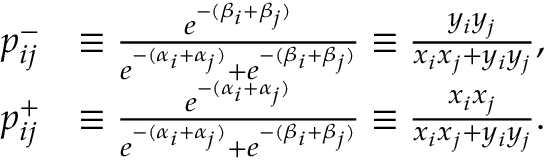Convert formula to latex. <formula><loc_0><loc_0><loc_500><loc_500>\begin{array} { r l } { p _ { i j } ^ { - } } & { \equiv \frac { e ^ { - ( \beta _ { i } + \beta _ { j } ) } } { e ^ { - ( \alpha _ { i } + \alpha _ { j } ) } + e ^ { - ( \beta _ { i } + \beta _ { j } ) } } \equiv \frac { y _ { i } y _ { j } } { x _ { i } x _ { j } + y _ { i } y _ { j } } , } \\ { p _ { i j } ^ { + } } & { \equiv \frac { e ^ { - ( \alpha _ { i } + \alpha _ { j } ) } } { e ^ { - ( \alpha _ { i } + \alpha _ { j } ) } + e ^ { - ( \beta _ { i } + \beta _ { j } ) } } \equiv \frac { x _ { i } x _ { j } } { x _ { i } x _ { j } + y _ { i } y _ { j } } . } \end{array}</formula> 